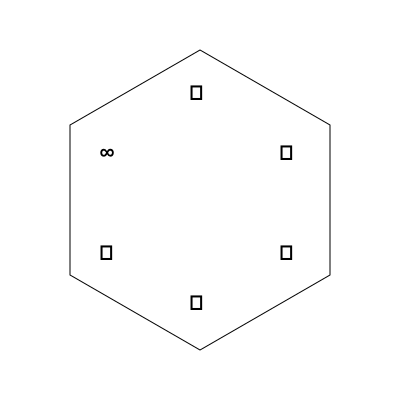In this hexagonal representation of philosophical concepts, symbols are arranged in a specific order. If the hexagon is rotated 120° clockwise and then reflected across its vertical axis, what will be the new position of the symbol representing "unity" (◯)? To solve this problem, we need to follow these steps:

1. Identify the initial position of the "unity" symbol (◯):
   It is initially located at the bottom-right vertex of the hexagon.

2. Rotate the hexagon 120° clockwise:
   - △ moves to where ☐ was
   - ☼ moves to where ✧ was
   - ◯ moves to where ∞ was
   - ☐ moves to where ◯ was
   - ✧ moves to where ☼ was
   - ∞ moves to where △ was

3. After rotation, ◯ is now at the top-left vertex.

4. Reflect the rotated hexagon across its vertical axis:
   - Top-left ◯ will move to top-right
   - Bottom-left ✧ will move to bottom-right
   - Top-right ☼ will move to top-left
   - Bottom-right ☐ will move to bottom-left
   - Top and bottom vertices (△ and ∞) remain unchanged

5. After reflection, ◯ is now at the top-right vertex of the hexagon.

This final position represents the new location of the "unity" symbol after the specified transformations.
Answer: Top-right vertex 